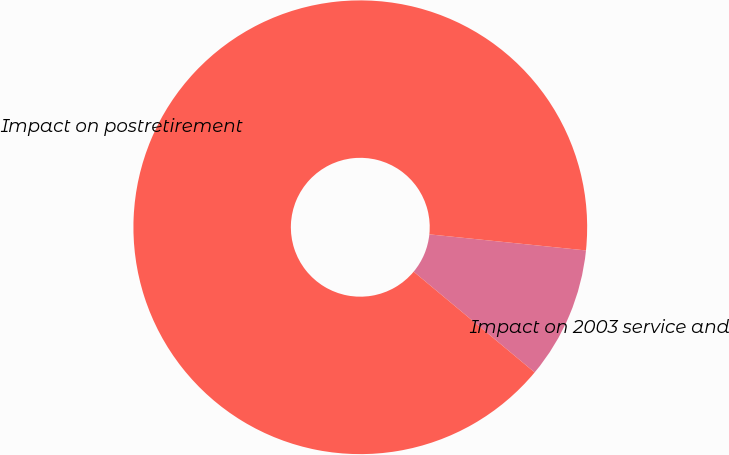Convert chart. <chart><loc_0><loc_0><loc_500><loc_500><pie_chart><fcel>Impact on 2003 service and<fcel>Impact on postretirement<nl><fcel>9.42%<fcel>90.58%<nl></chart> 